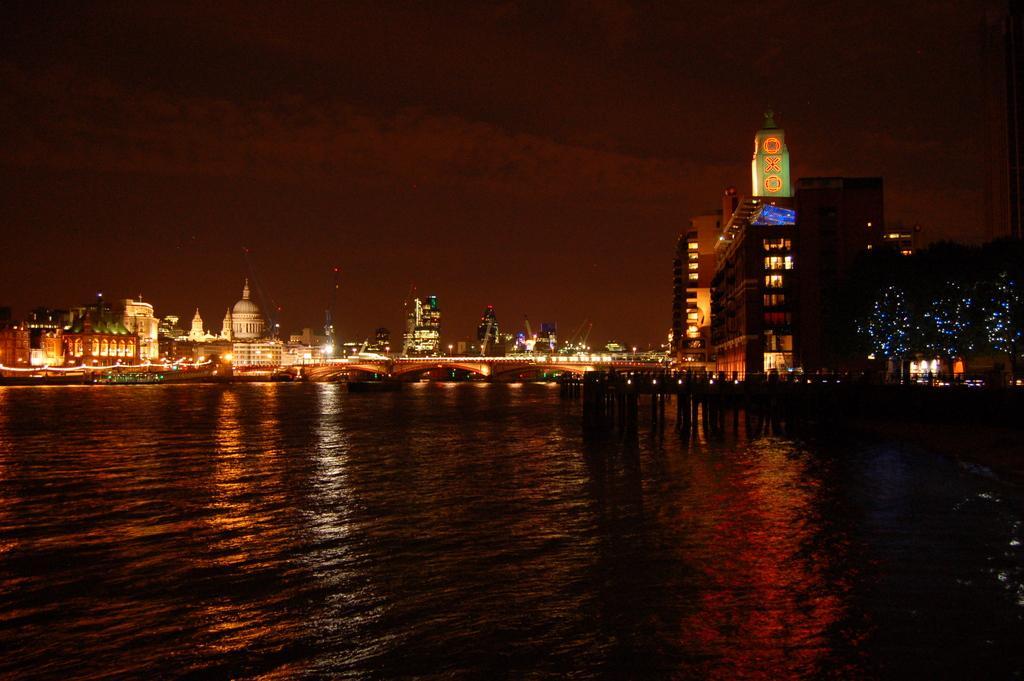Could you give a brief overview of what you see in this image? In this image we can see water, buildings, electric lights, towers, trees and sky. 